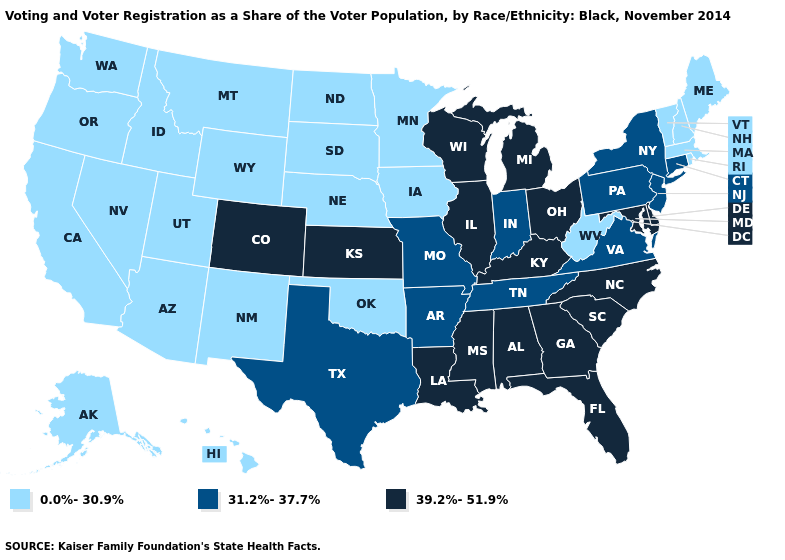Name the states that have a value in the range 39.2%-51.9%?
Quick response, please. Alabama, Colorado, Delaware, Florida, Georgia, Illinois, Kansas, Kentucky, Louisiana, Maryland, Michigan, Mississippi, North Carolina, Ohio, South Carolina, Wisconsin. Does Nebraska have the lowest value in the USA?
Write a very short answer. Yes. Name the states that have a value in the range 0.0%-30.9%?
Answer briefly. Alaska, Arizona, California, Hawaii, Idaho, Iowa, Maine, Massachusetts, Minnesota, Montana, Nebraska, Nevada, New Hampshire, New Mexico, North Dakota, Oklahoma, Oregon, Rhode Island, South Dakota, Utah, Vermont, Washington, West Virginia, Wyoming. Name the states that have a value in the range 39.2%-51.9%?
Be succinct. Alabama, Colorado, Delaware, Florida, Georgia, Illinois, Kansas, Kentucky, Louisiana, Maryland, Michigan, Mississippi, North Carolina, Ohio, South Carolina, Wisconsin. What is the lowest value in the South?
Write a very short answer. 0.0%-30.9%. Which states have the highest value in the USA?
Answer briefly. Alabama, Colorado, Delaware, Florida, Georgia, Illinois, Kansas, Kentucky, Louisiana, Maryland, Michigan, Mississippi, North Carolina, Ohio, South Carolina, Wisconsin. Name the states that have a value in the range 31.2%-37.7%?
Quick response, please. Arkansas, Connecticut, Indiana, Missouri, New Jersey, New York, Pennsylvania, Tennessee, Texas, Virginia. Name the states that have a value in the range 0.0%-30.9%?
Concise answer only. Alaska, Arizona, California, Hawaii, Idaho, Iowa, Maine, Massachusetts, Minnesota, Montana, Nebraska, Nevada, New Hampshire, New Mexico, North Dakota, Oklahoma, Oregon, Rhode Island, South Dakota, Utah, Vermont, Washington, West Virginia, Wyoming. Does Connecticut have the highest value in the Northeast?
Quick response, please. Yes. What is the value of Utah?
Answer briefly. 0.0%-30.9%. Name the states that have a value in the range 39.2%-51.9%?
Answer briefly. Alabama, Colorado, Delaware, Florida, Georgia, Illinois, Kansas, Kentucky, Louisiana, Maryland, Michigan, Mississippi, North Carolina, Ohio, South Carolina, Wisconsin. Does West Virginia have a lower value than North Carolina?
Keep it brief. Yes. What is the highest value in the South ?
Short answer required. 39.2%-51.9%. What is the highest value in the MidWest ?
Concise answer only. 39.2%-51.9%. 